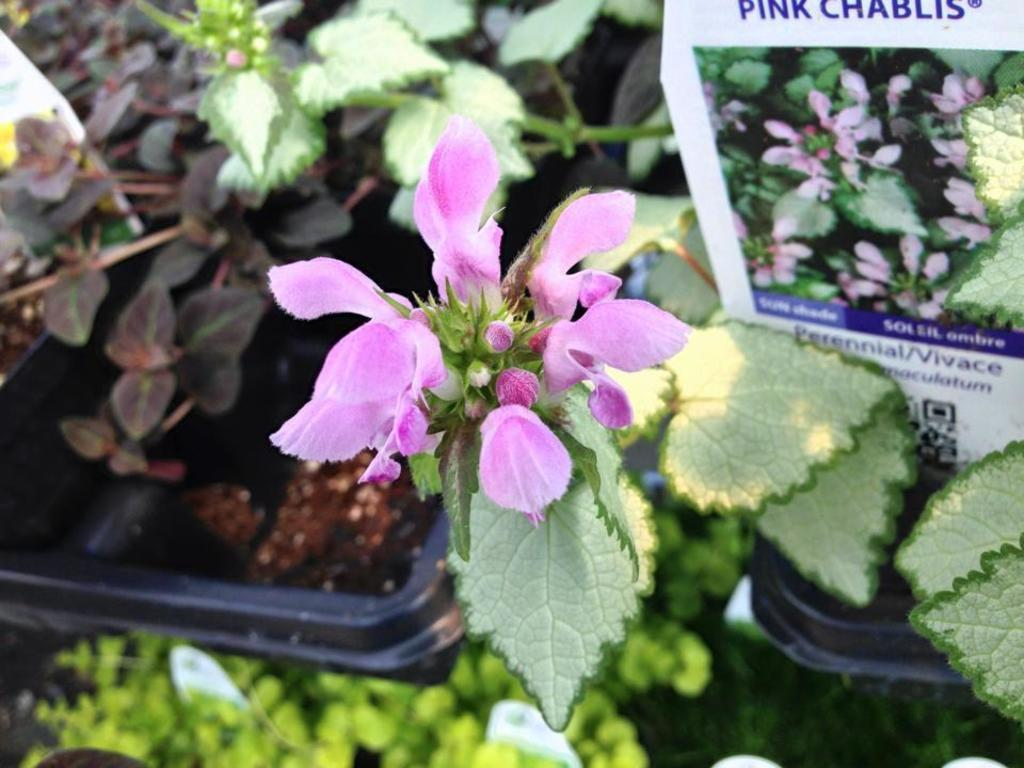What type of living organisms are present in the image? There are plants in the image. What are the plants producing? Flowers are grown on the plants. What is the color of the flowers? The flowers are pink in color. What type of invention is being used to improve the acoustics in the image? There is no mention of an invention or acoustics in the image; it features plants with pink flowers. 